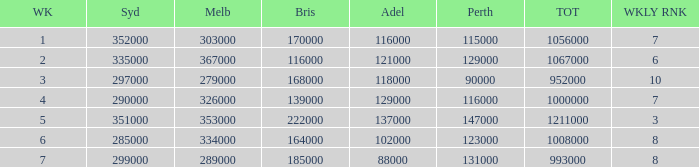What is the highest number of Brisbane viewers? 222000.0. 